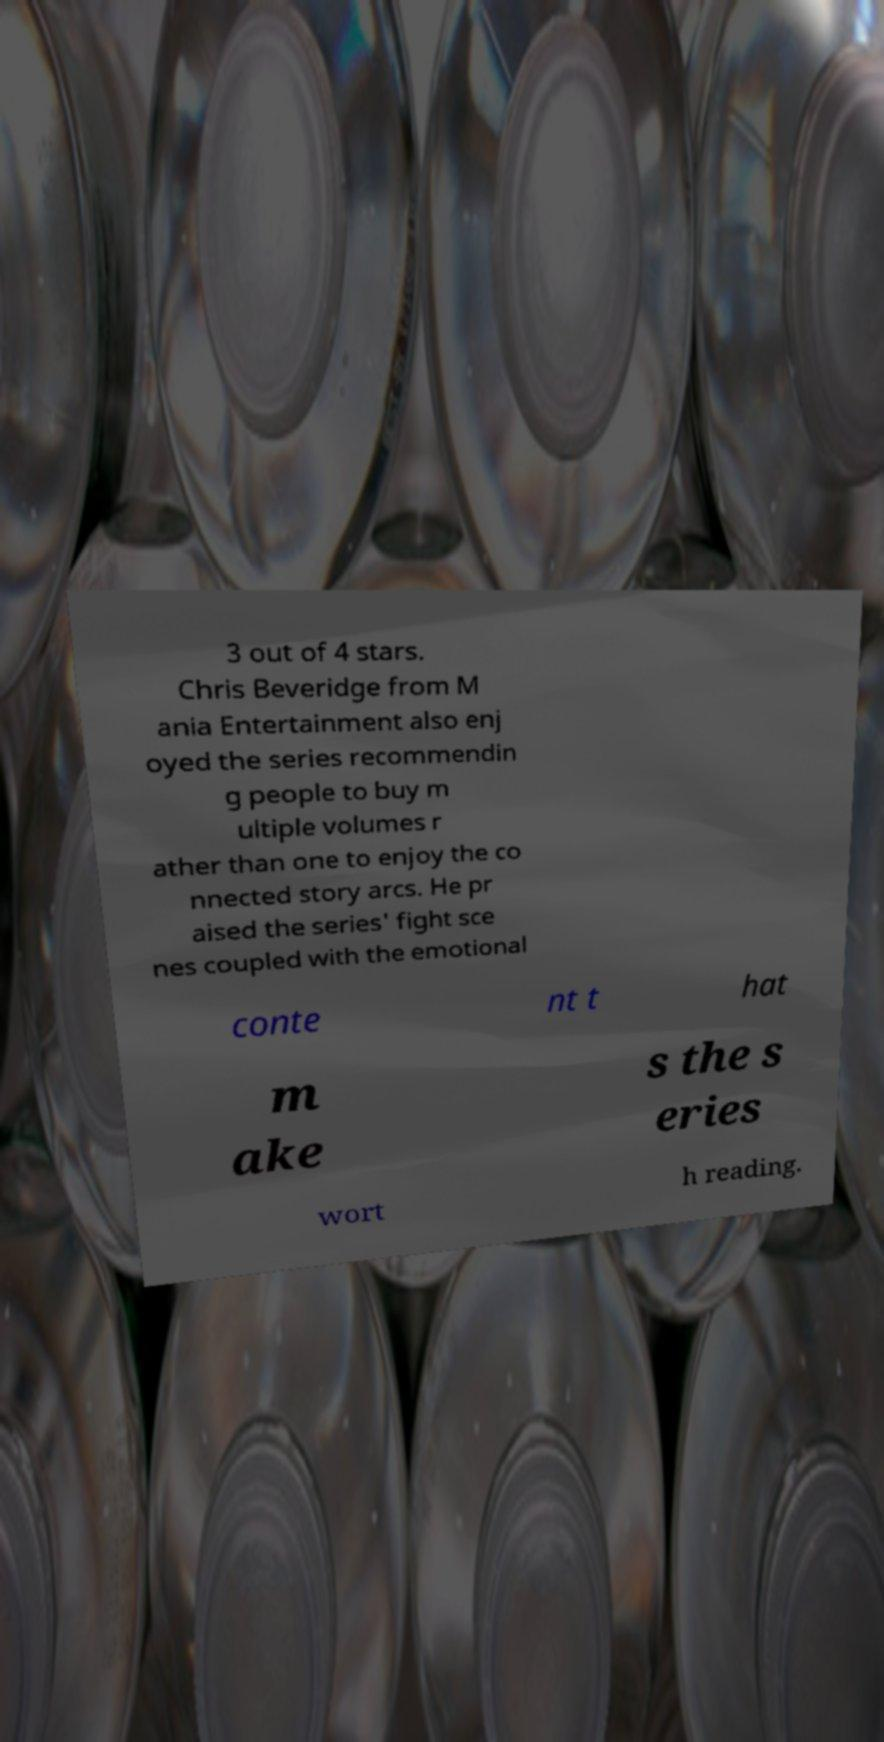Could you extract and type out the text from this image? 3 out of 4 stars. Chris Beveridge from M ania Entertainment also enj oyed the series recommendin g people to buy m ultiple volumes r ather than one to enjoy the co nnected story arcs. He pr aised the series' fight sce nes coupled with the emotional conte nt t hat m ake s the s eries wort h reading. 